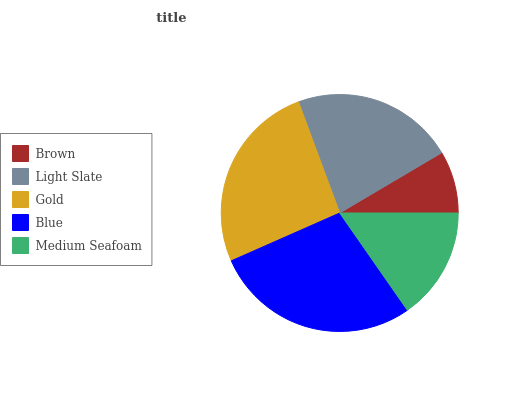Is Brown the minimum?
Answer yes or no. Yes. Is Blue the maximum?
Answer yes or no. Yes. Is Light Slate the minimum?
Answer yes or no. No. Is Light Slate the maximum?
Answer yes or no. No. Is Light Slate greater than Brown?
Answer yes or no. Yes. Is Brown less than Light Slate?
Answer yes or no. Yes. Is Brown greater than Light Slate?
Answer yes or no. No. Is Light Slate less than Brown?
Answer yes or no. No. Is Light Slate the high median?
Answer yes or no. Yes. Is Light Slate the low median?
Answer yes or no. Yes. Is Gold the high median?
Answer yes or no. No. Is Blue the low median?
Answer yes or no. No. 